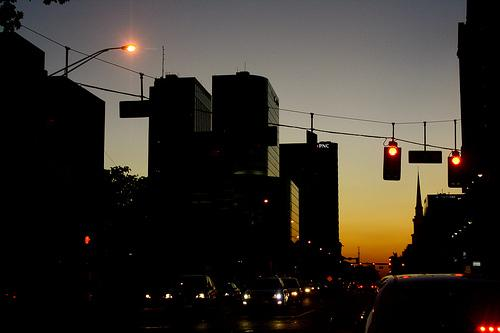If you were to create a painting of this image, which elements would you emphasize and why? I would emphasize the tall buildings, contrasting their silhouettes against the backdrop of the yellow and red setting sun, and highlight the headlights and tail lights of approaching cars, to create a sense of depth and urban energy. For product advertisement purposes, mention the prominent colors and objects related to lighting in the image. Experience the vibrant hues of red brake lights and glowing yellow setting sun, combined with the solemn glow of the streetlight, illuminating the world around you. Specify what the sign for pedestrians is telling them to do. The sign is telling pedestrians not to cross the street. Describe the image in the style of a haiku poem. Headlights cut through dusk. Which object in the image can be related to safety, and what is its function? The traffic lights are related to safety, as they regulate traffic flow and prevent accidents. Imagine you are driving in the scene. Describe your surroundings and the signs you must obey. As I drive along the dimly lit street, surrounded by tall buildings, I'm greeted by the yellow and red glow of the setting sun. Ahead, I see approaching cars with their headlights on, and I must obey the red traffic lights and the sign warning pedestrians not to cross the street. In a poetic manner, describe the scene of the cars in the image. Approaching cars gracefully dance through the dimly lit street; their headlights pierce through the night like glowing gazes from celestial beings. Narrate the scene from the perspective of a tree in the image. As a silent observer, I've witnessed the bustling city life, the tall buildings looming over me, cars racing past with their headlights ablaze, and traffic lights dictating the flow of life, all while the setting sun casts its fiery embrace. Identify the color and number of traffic lights in the image. There are two red traffic lights in the image. What is the main feature of the sky in the image? The main feature of the sky is the yellow and red glow from the setting sun. 